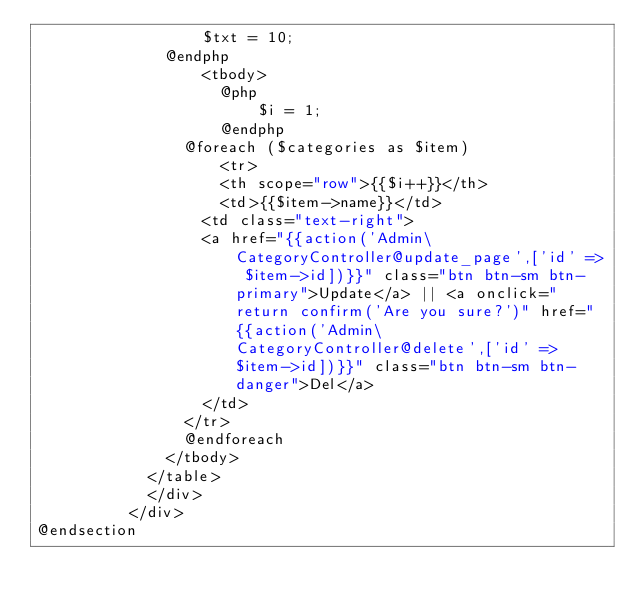<code> <loc_0><loc_0><loc_500><loc_500><_PHP_>                  $txt = 10;
              @endphp
                  <tbody>
                    @php
                        $i = 1;
                    @endphp
                @foreach ($categories as $item)
                    <tr>
                    <th scope="row">{{$i++}}</th>
                    <td>{{$item->name}}</td>
                  <td class="text-right">
                  <a href="{{action('Admin\CategoryController@update_page',['id' => $item->id])}}" class="btn btn-sm btn-primary">Update</a> || <a onclick="return confirm('Are you sure?')" href="{{action('Admin\CategoryController@delete',['id' => $item->id])}}" class="btn btn-sm btn-danger">Del</a>
                  </td>
                </tr>
                @endforeach
              </tbody>
            </table>
            </div>
          </div>
@endsection
</code> 